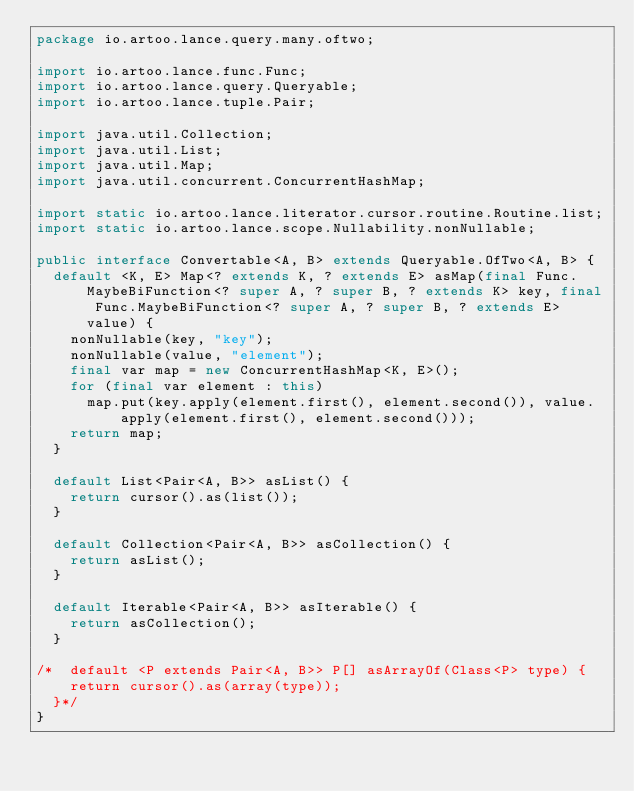<code> <loc_0><loc_0><loc_500><loc_500><_Java_>package io.artoo.lance.query.many.oftwo;

import io.artoo.lance.func.Func;
import io.artoo.lance.query.Queryable;
import io.artoo.lance.tuple.Pair;

import java.util.Collection;
import java.util.List;
import java.util.Map;
import java.util.concurrent.ConcurrentHashMap;

import static io.artoo.lance.literator.cursor.routine.Routine.list;
import static io.artoo.lance.scope.Nullability.nonNullable;

public interface Convertable<A, B> extends Queryable.OfTwo<A, B> {
  default <K, E> Map<? extends K, ? extends E> asMap(final Func.MaybeBiFunction<? super A, ? super B, ? extends K> key, final Func.MaybeBiFunction<? super A, ? super B, ? extends E> value) {
    nonNullable(key, "key");
    nonNullable(value, "element");
    final var map = new ConcurrentHashMap<K, E>();
    for (final var element : this)
      map.put(key.apply(element.first(), element.second()), value.apply(element.first(), element.second()));
    return map;
  }

  default List<Pair<A, B>> asList() {
    return cursor().as(list());
  }

  default Collection<Pair<A, B>> asCollection() {
    return asList();
  }

  default Iterable<Pair<A, B>> asIterable() {
    return asCollection();
  }

/*  default <P extends Pair<A, B>> P[] asArrayOf(Class<P> type) {
    return cursor().as(array(type));
  }*/
}
</code> 